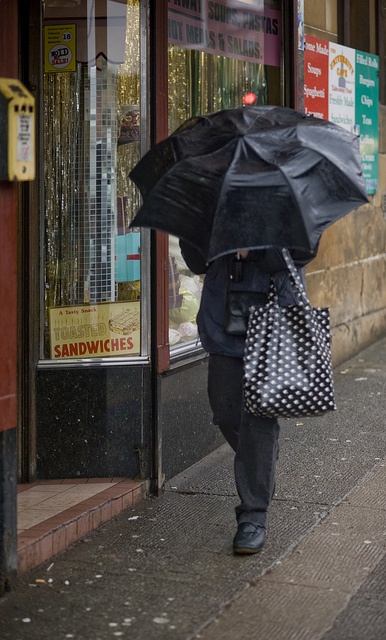Describe the objects in this image and their specific colors. I can see umbrella in black, gray, and darkgray tones and people in black, gray, and darkgray tones in this image. 